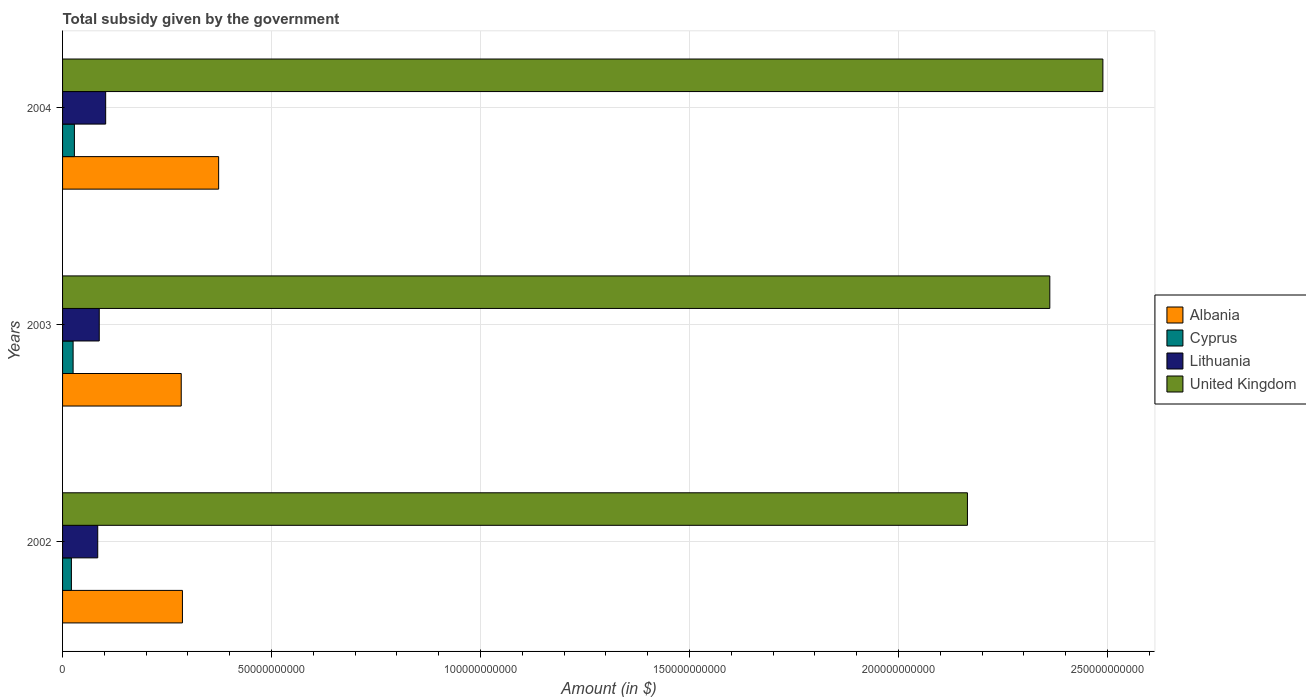How many different coloured bars are there?
Offer a very short reply. 4. Are the number of bars per tick equal to the number of legend labels?
Give a very brief answer. Yes. Are the number of bars on each tick of the Y-axis equal?
Give a very brief answer. Yes. How many bars are there on the 3rd tick from the top?
Your answer should be compact. 4. How many bars are there on the 3rd tick from the bottom?
Offer a very short reply. 4. What is the total revenue collected by the government in Albania in 2003?
Your response must be concise. 2.84e+1. Across all years, what is the maximum total revenue collected by the government in Cyprus?
Provide a short and direct response. 2.83e+09. Across all years, what is the minimum total revenue collected by the government in Albania?
Your response must be concise. 2.84e+1. In which year was the total revenue collected by the government in Cyprus maximum?
Your response must be concise. 2004. What is the total total revenue collected by the government in Albania in the graph?
Offer a very short reply. 9.44e+1. What is the difference between the total revenue collected by the government in United Kingdom in 2002 and that in 2004?
Provide a succinct answer. -3.24e+1. What is the difference between the total revenue collected by the government in United Kingdom in 2003 and the total revenue collected by the government in Albania in 2002?
Offer a terse response. 2.08e+11. What is the average total revenue collected by the government in United Kingdom per year?
Make the answer very short. 2.34e+11. In the year 2003, what is the difference between the total revenue collected by the government in Lithuania and total revenue collected by the government in Cyprus?
Give a very brief answer. 6.25e+09. What is the ratio of the total revenue collected by the government in Cyprus in 2002 to that in 2003?
Your answer should be very brief. 0.84. Is the difference between the total revenue collected by the government in Lithuania in 2003 and 2004 greater than the difference between the total revenue collected by the government in Cyprus in 2003 and 2004?
Your answer should be very brief. No. What is the difference between the highest and the second highest total revenue collected by the government in Lithuania?
Offer a terse response. 1.54e+09. What is the difference between the highest and the lowest total revenue collected by the government in United Kingdom?
Offer a very short reply. 3.24e+1. In how many years, is the total revenue collected by the government in United Kingdom greater than the average total revenue collected by the government in United Kingdom taken over all years?
Make the answer very short. 2. Is the sum of the total revenue collected by the government in Lithuania in 2002 and 2003 greater than the maximum total revenue collected by the government in Cyprus across all years?
Keep it short and to the point. Yes. Is it the case that in every year, the sum of the total revenue collected by the government in Albania and total revenue collected by the government in United Kingdom is greater than the sum of total revenue collected by the government in Cyprus and total revenue collected by the government in Lithuania?
Your response must be concise. Yes. What does the 4th bar from the top in 2004 represents?
Your answer should be very brief. Albania. How many years are there in the graph?
Offer a terse response. 3. Are the values on the major ticks of X-axis written in scientific E-notation?
Your answer should be very brief. No. Does the graph contain any zero values?
Keep it short and to the point. No. Does the graph contain grids?
Ensure brevity in your answer.  Yes. Where does the legend appear in the graph?
Offer a very short reply. Center right. How many legend labels are there?
Provide a succinct answer. 4. What is the title of the graph?
Give a very brief answer. Total subsidy given by the government. Does "Korea (Republic)" appear as one of the legend labels in the graph?
Your response must be concise. No. What is the label or title of the X-axis?
Your answer should be compact. Amount (in $). What is the label or title of the Y-axis?
Offer a very short reply. Years. What is the Amount (in $) of Albania in 2002?
Make the answer very short. 2.87e+1. What is the Amount (in $) of Cyprus in 2002?
Your response must be concise. 2.11e+09. What is the Amount (in $) in Lithuania in 2002?
Provide a succinct answer. 8.41e+09. What is the Amount (in $) of United Kingdom in 2002?
Make the answer very short. 2.16e+11. What is the Amount (in $) of Albania in 2003?
Your answer should be very brief. 2.84e+1. What is the Amount (in $) in Cyprus in 2003?
Ensure brevity in your answer.  2.52e+09. What is the Amount (in $) of Lithuania in 2003?
Make the answer very short. 8.77e+09. What is the Amount (in $) in United Kingdom in 2003?
Your answer should be compact. 2.36e+11. What is the Amount (in $) in Albania in 2004?
Make the answer very short. 3.73e+1. What is the Amount (in $) in Cyprus in 2004?
Keep it short and to the point. 2.83e+09. What is the Amount (in $) in Lithuania in 2004?
Keep it short and to the point. 1.03e+1. What is the Amount (in $) of United Kingdom in 2004?
Provide a succinct answer. 2.49e+11. Across all years, what is the maximum Amount (in $) of Albania?
Provide a short and direct response. 3.73e+1. Across all years, what is the maximum Amount (in $) in Cyprus?
Offer a terse response. 2.83e+09. Across all years, what is the maximum Amount (in $) in Lithuania?
Keep it short and to the point. 1.03e+1. Across all years, what is the maximum Amount (in $) in United Kingdom?
Provide a short and direct response. 2.49e+11. Across all years, what is the minimum Amount (in $) of Albania?
Keep it short and to the point. 2.84e+1. Across all years, what is the minimum Amount (in $) of Cyprus?
Ensure brevity in your answer.  2.11e+09. Across all years, what is the minimum Amount (in $) of Lithuania?
Provide a succinct answer. 8.41e+09. Across all years, what is the minimum Amount (in $) of United Kingdom?
Keep it short and to the point. 2.16e+11. What is the total Amount (in $) of Albania in the graph?
Your response must be concise. 9.44e+1. What is the total Amount (in $) of Cyprus in the graph?
Offer a terse response. 7.47e+09. What is the total Amount (in $) of Lithuania in the graph?
Offer a terse response. 2.75e+1. What is the total Amount (in $) in United Kingdom in the graph?
Offer a terse response. 7.02e+11. What is the difference between the Amount (in $) of Albania in 2002 and that in 2003?
Offer a terse response. 2.91e+08. What is the difference between the Amount (in $) in Cyprus in 2002 and that in 2003?
Your answer should be very brief. -4.07e+08. What is the difference between the Amount (in $) in Lithuania in 2002 and that in 2003?
Your answer should be compact. -3.61e+08. What is the difference between the Amount (in $) in United Kingdom in 2002 and that in 2003?
Your answer should be compact. -1.97e+1. What is the difference between the Amount (in $) of Albania in 2002 and that in 2004?
Keep it short and to the point. -8.66e+09. What is the difference between the Amount (in $) in Cyprus in 2002 and that in 2004?
Give a very brief answer. -7.20e+08. What is the difference between the Amount (in $) of Lithuania in 2002 and that in 2004?
Keep it short and to the point. -1.90e+09. What is the difference between the Amount (in $) in United Kingdom in 2002 and that in 2004?
Make the answer very short. -3.24e+1. What is the difference between the Amount (in $) of Albania in 2003 and that in 2004?
Offer a terse response. -8.95e+09. What is the difference between the Amount (in $) in Cyprus in 2003 and that in 2004?
Your answer should be very brief. -3.14e+08. What is the difference between the Amount (in $) in Lithuania in 2003 and that in 2004?
Give a very brief answer. -1.54e+09. What is the difference between the Amount (in $) in United Kingdom in 2003 and that in 2004?
Your answer should be very brief. -1.27e+1. What is the difference between the Amount (in $) in Albania in 2002 and the Amount (in $) in Cyprus in 2003?
Your answer should be compact. 2.62e+1. What is the difference between the Amount (in $) in Albania in 2002 and the Amount (in $) in Lithuania in 2003?
Provide a short and direct response. 1.99e+1. What is the difference between the Amount (in $) of Albania in 2002 and the Amount (in $) of United Kingdom in 2003?
Provide a succinct answer. -2.08e+11. What is the difference between the Amount (in $) in Cyprus in 2002 and the Amount (in $) in Lithuania in 2003?
Keep it short and to the point. -6.66e+09. What is the difference between the Amount (in $) of Cyprus in 2002 and the Amount (in $) of United Kingdom in 2003?
Your answer should be very brief. -2.34e+11. What is the difference between the Amount (in $) of Lithuania in 2002 and the Amount (in $) of United Kingdom in 2003?
Offer a terse response. -2.28e+11. What is the difference between the Amount (in $) in Albania in 2002 and the Amount (in $) in Cyprus in 2004?
Ensure brevity in your answer.  2.58e+1. What is the difference between the Amount (in $) of Albania in 2002 and the Amount (in $) of Lithuania in 2004?
Your answer should be compact. 1.84e+1. What is the difference between the Amount (in $) in Albania in 2002 and the Amount (in $) in United Kingdom in 2004?
Keep it short and to the point. -2.20e+11. What is the difference between the Amount (in $) in Cyprus in 2002 and the Amount (in $) in Lithuania in 2004?
Give a very brief answer. -8.20e+09. What is the difference between the Amount (in $) in Cyprus in 2002 and the Amount (in $) in United Kingdom in 2004?
Give a very brief answer. -2.47e+11. What is the difference between the Amount (in $) in Lithuania in 2002 and the Amount (in $) in United Kingdom in 2004?
Give a very brief answer. -2.40e+11. What is the difference between the Amount (in $) in Albania in 2003 and the Amount (in $) in Cyprus in 2004?
Your answer should be compact. 2.56e+1. What is the difference between the Amount (in $) of Albania in 2003 and the Amount (in $) of Lithuania in 2004?
Offer a very short reply. 1.81e+1. What is the difference between the Amount (in $) in Albania in 2003 and the Amount (in $) in United Kingdom in 2004?
Offer a very short reply. -2.20e+11. What is the difference between the Amount (in $) of Cyprus in 2003 and the Amount (in $) of Lithuania in 2004?
Your answer should be very brief. -7.79e+09. What is the difference between the Amount (in $) of Cyprus in 2003 and the Amount (in $) of United Kingdom in 2004?
Your answer should be very brief. -2.46e+11. What is the difference between the Amount (in $) in Lithuania in 2003 and the Amount (in $) in United Kingdom in 2004?
Keep it short and to the point. -2.40e+11. What is the average Amount (in $) of Albania per year?
Ensure brevity in your answer.  3.15e+1. What is the average Amount (in $) in Cyprus per year?
Give a very brief answer. 2.49e+09. What is the average Amount (in $) in Lithuania per year?
Provide a succinct answer. 9.17e+09. What is the average Amount (in $) in United Kingdom per year?
Your answer should be very brief. 2.34e+11. In the year 2002, what is the difference between the Amount (in $) in Albania and Amount (in $) in Cyprus?
Ensure brevity in your answer.  2.66e+1. In the year 2002, what is the difference between the Amount (in $) in Albania and Amount (in $) in Lithuania?
Provide a short and direct response. 2.03e+1. In the year 2002, what is the difference between the Amount (in $) of Albania and Amount (in $) of United Kingdom?
Your answer should be compact. -1.88e+11. In the year 2002, what is the difference between the Amount (in $) of Cyprus and Amount (in $) of Lithuania?
Keep it short and to the point. -6.30e+09. In the year 2002, what is the difference between the Amount (in $) in Cyprus and Amount (in $) in United Kingdom?
Keep it short and to the point. -2.14e+11. In the year 2002, what is the difference between the Amount (in $) of Lithuania and Amount (in $) of United Kingdom?
Ensure brevity in your answer.  -2.08e+11. In the year 2003, what is the difference between the Amount (in $) in Albania and Amount (in $) in Cyprus?
Provide a short and direct response. 2.59e+1. In the year 2003, what is the difference between the Amount (in $) of Albania and Amount (in $) of Lithuania?
Ensure brevity in your answer.  1.96e+1. In the year 2003, what is the difference between the Amount (in $) in Albania and Amount (in $) in United Kingdom?
Keep it short and to the point. -2.08e+11. In the year 2003, what is the difference between the Amount (in $) in Cyprus and Amount (in $) in Lithuania?
Make the answer very short. -6.25e+09. In the year 2003, what is the difference between the Amount (in $) of Cyprus and Amount (in $) of United Kingdom?
Provide a succinct answer. -2.34e+11. In the year 2003, what is the difference between the Amount (in $) of Lithuania and Amount (in $) of United Kingdom?
Give a very brief answer. -2.27e+11. In the year 2004, what is the difference between the Amount (in $) of Albania and Amount (in $) of Cyprus?
Ensure brevity in your answer.  3.45e+1. In the year 2004, what is the difference between the Amount (in $) of Albania and Amount (in $) of Lithuania?
Offer a terse response. 2.70e+1. In the year 2004, what is the difference between the Amount (in $) in Albania and Amount (in $) in United Kingdom?
Your response must be concise. -2.12e+11. In the year 2004, what is the difference between the Amount (in $) in Cyprus and Amount (in $) in Lithuania?
Offer a very short reply. -7.48e+09. In the year 2004, what is the difference between the Amount (in $) in Cyprus and Amount (in $) in United Kingdom?
Offer a terse response. -2.46e+11. In the year 2004, what is the difference between the Amount (in $) of Lithuania and Amount (in $) of United Kingdom?
Your answer should be very brief. -2.39e+11. What is the ratio of the Amount (in $) of Albania in 2002 to that in 2003?
Offer a terse response. 1.01. What is the ratio of the Amount (in $) of Cyprus in 2002 to that in 2003?
Offer a terse response. 0.84. What is the ratio of the Amount (in $) in Lithuania in 2002 to that in 2003?
Provide a short and direct response. 0.96. What is the ratio of the Amount (in $) of United Kingdom in 2002 to that in 2003?
Your answer should be very brief. 0.92. What is the ratio of the Amount (in $) of Albania in 2002 to that in 2004?
Provide a succinct answer. 0.77. What is the ratio of the Amount (in $) in Cyprus in 2002 to that in 2004?
Your answer should be compact. 0.75. What is the ratio of the Amount (in $) of Lithuania in 2002 to that in 2004?
Your response must be concise. 0.82. What is the ratio of the Amount (in $) of United Kingdom in 2002 to that in 2004?
Your answer should be compact. 0.87. What is the ratio of the Amount (in $) in Albania in 2003 to that in 2004?
Offer a terse response. 0.76. What is the ratio of the Amount (in $) of Cyprus in 2003 to that in 2004?
Offer a very short reply. 0.89. What is the ratio of the Amount (in $) of Lithuania in 2003 to that in 2004?
Make the answer very short. 0.85. What is the ratio of the Amount (in $) of United Kingdom in 2003 to that in 2004?
Provide a short and direct response. 0.95. What is the difference between the highest and the second highest Amount (in $) in Albania?
Your answer should be very brief. 8.66e+09. What is the difference between the highest and the second highest Amount (in $) in Cyprus?
Offer a terse response. 3.14e+08. What is the difference between the highest and the second highest Amount (in $) of Lithuania?
Give a very brief answer. 1.54e+09. What is the difference between the highest and the second highest Amount (in $) of United Kingdom?
Your answer should be very brief. 1.27e+1. What is the difference between the highest and the lowest Amount (in $) of Albania?
Ensure brevity in your answer.  8.95e+09. What is the difference between the highest and the lowest Amount (in $) in Cyprus?
Offer a very short reply. 7.20e+08. What is the difference between the highest and the lowest Amount (in $) of Lithuania?
Ensure brevity in your answer.  1.90e+09. What is the difference between the highest and the lowest Amount (in $) in United Kingdom?
Make the answer very short. 3.24e+1. 